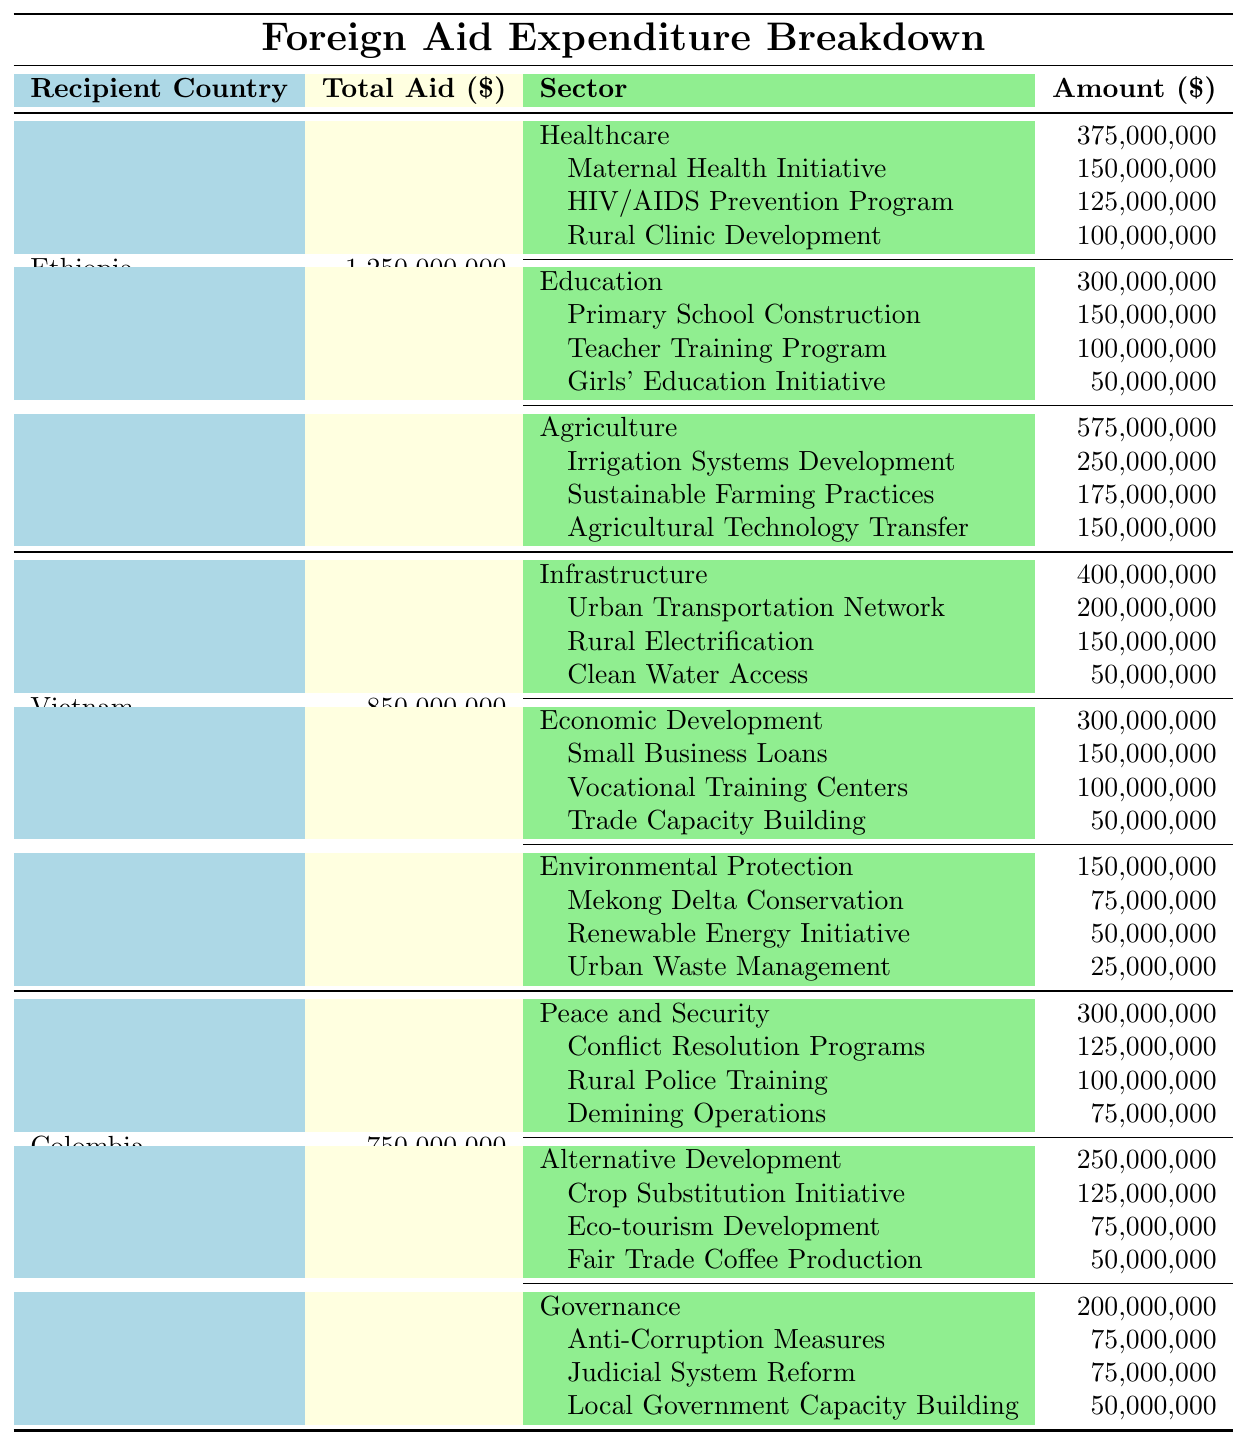What is the total foreign aid expenditure for Ethiopia? The table shows that the total aid for Ethiopia is indicated directly under the "Total Aid" column, which lists the amount as 1,250,000,000.
Answer: 1,250,000,000 How much aid is allocated to the healthcare sector in Vietnam? Referring to the "Healthcare" row under Vietnam, the amount indicated in the "Amount" column is 400,000,000.
Answer: 400,000,000 Which country received the least amount of total aid? Comparing the total aid amounts across Ethiopia (1,250,000,000), Vietnam (850,000,000), and Colombia (750,000,000), Colombia has the lowest total aid amount at 750,000,000.
Answer: Colombia How much more aid does Ethiopia receive compared to Colombia? The total aid for Ethiopia is 1,250,000,000 and for Colombia is 750,000,000. The difference is calculated as 1,250,000,000 - 750,000,000 = 500,000,000.
Answer: 500,000,000 What is the total amount of aid for education projects in Ethiopia? The table lists aid under the education sector for Ethiopia as 300,000,000, and the projects included are 150,000,000, 100,000,000, and 50,000,000, which add up to 300,000,000, confirming the sector amount.
Answer: 300,000,000 What percentage of Vietnam's total aid is allocated to infrastructure projects? Vietnam's total aid is 850,000,000, and the amount allocated for infrastructure is 400,000,000. The percentage is calculated by (400,000,000 / 850,000,000) * 100, which is approximately 47.06%.
Answer: 47.06% How much aid does Colombia allocate to peace and security projects compared to governance projects? The aid for peace and security projects is 300,000,000, while the governance projects receive 200,000,000. The difference is 300,000,000 - 200,000,000 = 100,000,000, indicating peace and security has more funding by this amount.
Answer: 100,000,000 Is there a project budget for maternal health initiatives in Ethiopia? The table specifically names "Maternal Health Initiative" under the healthcare sector in Ethiopia with a budget of 150,000,000, confirming that this project is indeed funded.
Answer: Yes Which sector receives the highest funding in Ethiopia? In Ethiopia, the sector amounts are 375,000,000 for healthcare, 300,000,000 for education, and 575,000,000 for agriculture. Therefore, agriculture, with 575,000,000, receives the most funding.
Answer: Agriculture If the projects in Vietnam's environmental protection sector are combined, what is their total funding? The projects listed are 75,000,000, 50,000,000, and 25,000,000. Adding these amounts together: 75,000,000 + 50,000,000 + 25,000,000 = 150,000,000 confirms the total for the sector.
Answer: 150,000,000 